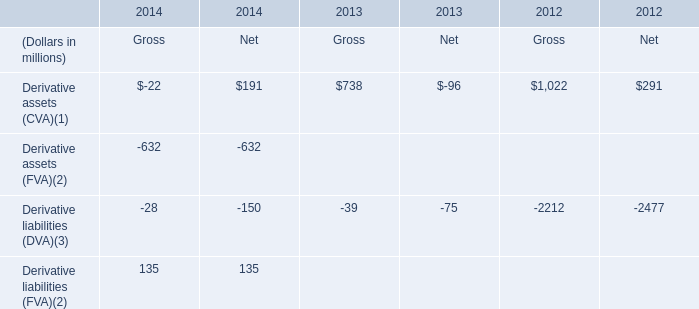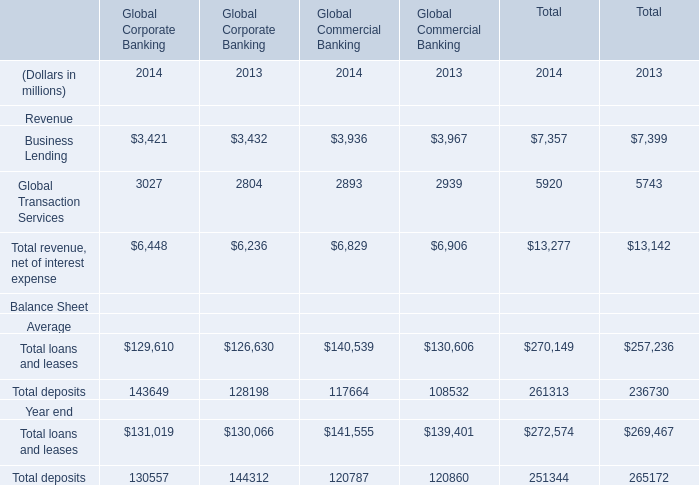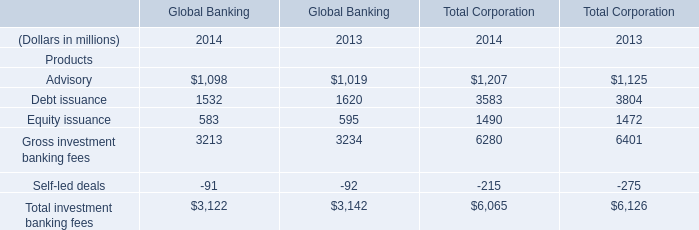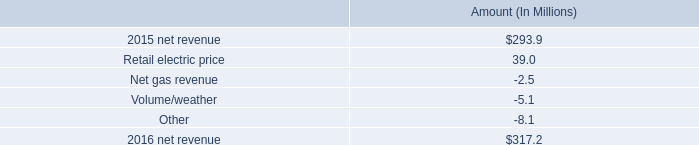what was the combined impact in millions on 2016 net revenue from the net gas revenue adjustment , the volume/weather adjustment , and other adjustments? 
Computations: ((-2.5 + -5.1) + -8.1)
Answer: -15.7. 